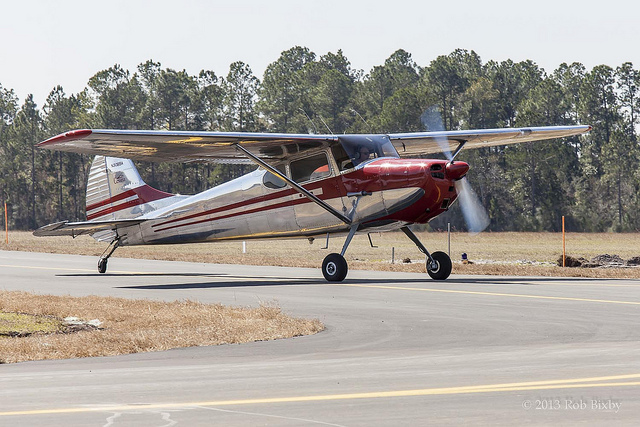Identify the text displayed in this image. 2013 Rob 